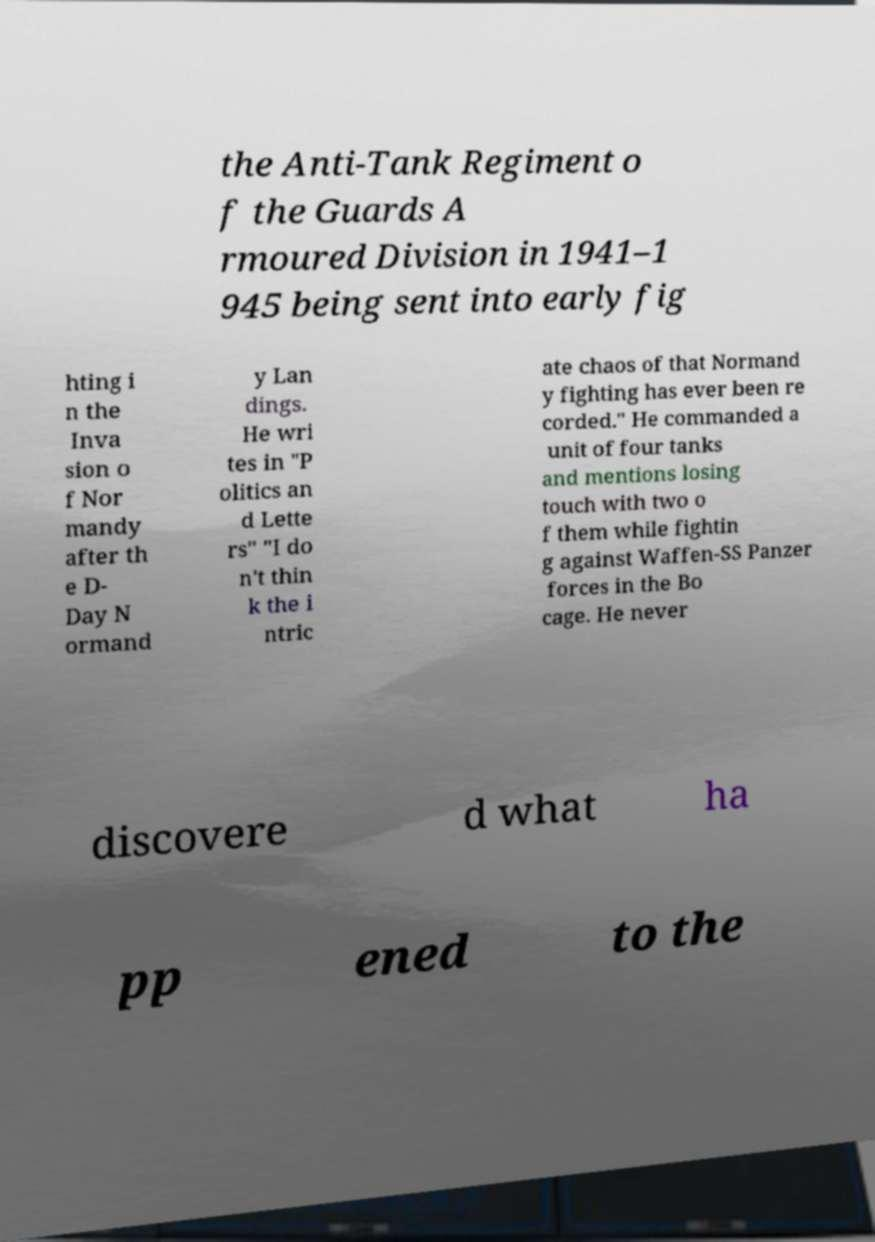Please read and relay the text visible in this image. What does it say? the Anti-Tank Regiment o f the Guards A rmoured Division in 1941–1 945 being sent into early fig hting i n the Inva sion o f Nor mandy after th e D- Day N ormand y Lan dings. He wri tes in "P olitics an d Lette rs" "I do n't thin k the i ntric ate chaos of that Normand y fighting has ever been re corded." He commanded a unit of four tanks and mentions losing touch with two o f them while fightin g against Waffen-SS Panzer forces in the Bo cage. He never discovere d what ha pp ened to the 